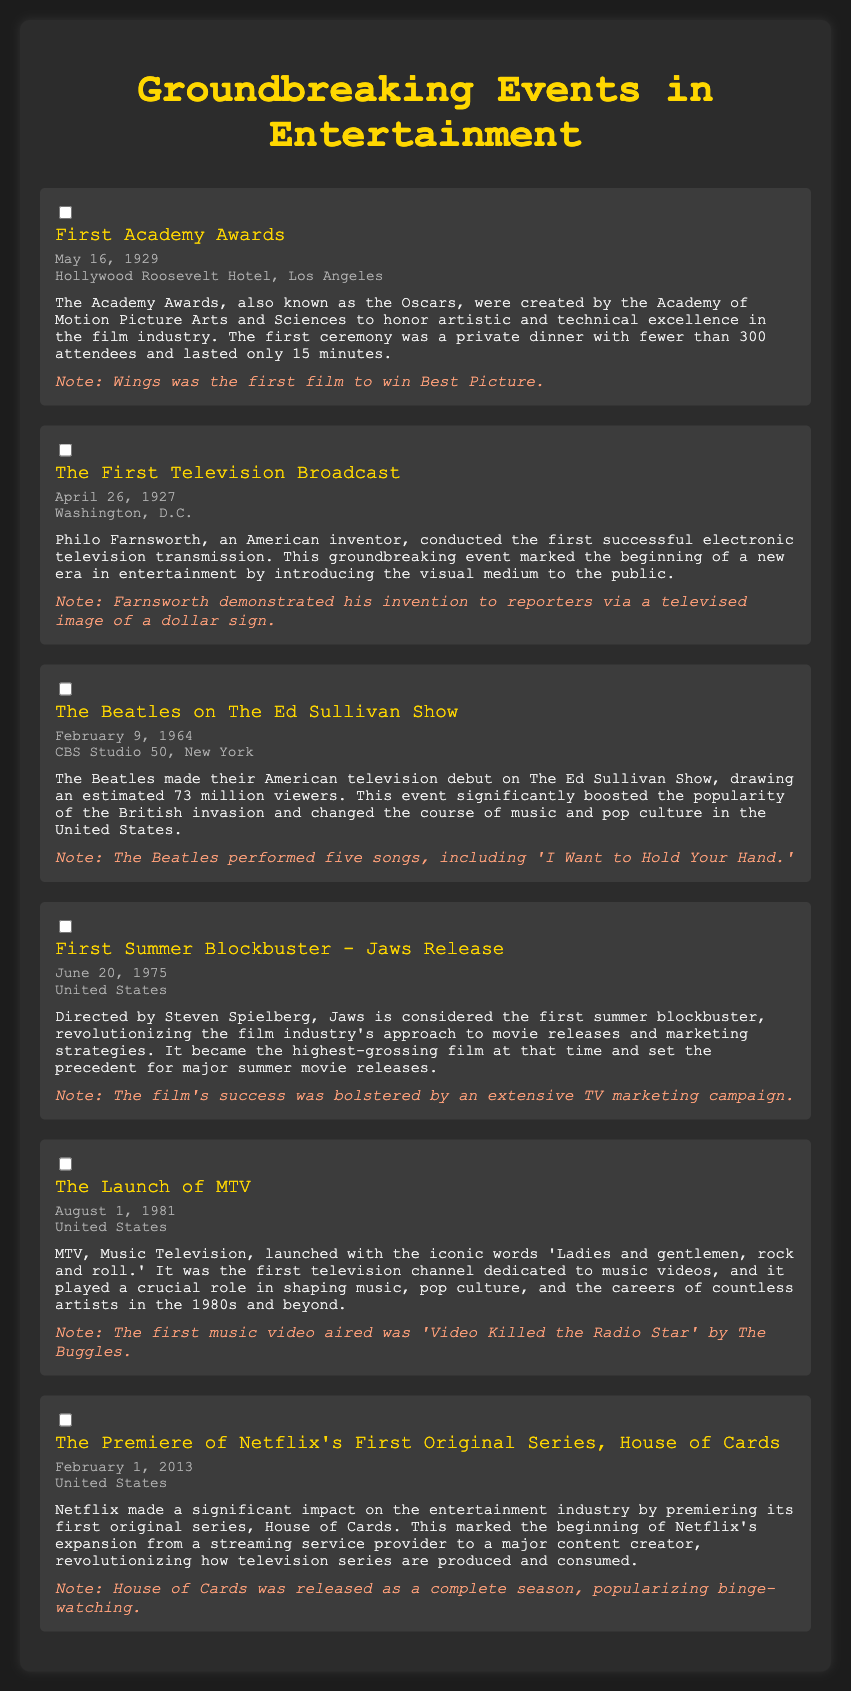what date was the first Academy Awards held? The first Academy Awards took place on May 16, 1929.
Answer: May 16, 1929 who hosted The Beatles' American television debut? The Beatles made their American television debut on The Ed Sullivan Show.
Answer: The Ed Sullivan Show what was the first film to win Best Picture? The first film to win Best Picture at the Academy Awards was Wings.
Answer: Wings when did MTV launch? MTV launched on August 1, 1981.
Answer: August 1, 1981 which series was Netflix's first original series? The first original series released by Netflix was House of Cards.
Answer: House of Cards how many viewers did The Beatles attract on The Ed Sullivan Show? The Beatles attracted an estimated 73 million viewers during their appearance.
Answer: 73 million which event is considered the first summer blockbuster? Jaws is regarded as the first summer blockbuster film.
Answer: Jaws what significant impact did House of Cards have on television? House of Cards popularized binge-watching as all episodes were released at once.
Answer: Binge-watching where was the first television broadcast conducted? The first television broadcast was conducted in Washington, D.C.
Answer: Washington, D.C 